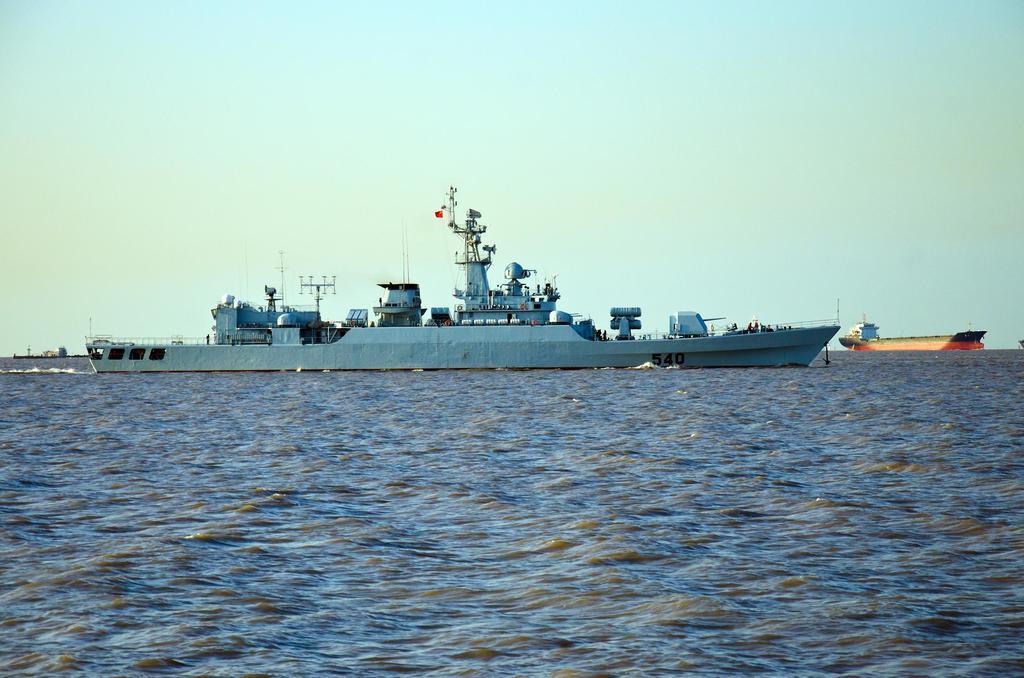How would you summarize this image in a sentence or two? In this picture we can see blue color ship on the water. On the ship we can see towers, poles, fencing, flags and other objects. On the right we can see a cargo ship. On the top we can see sky and clouds. In the background we can see ocean. 